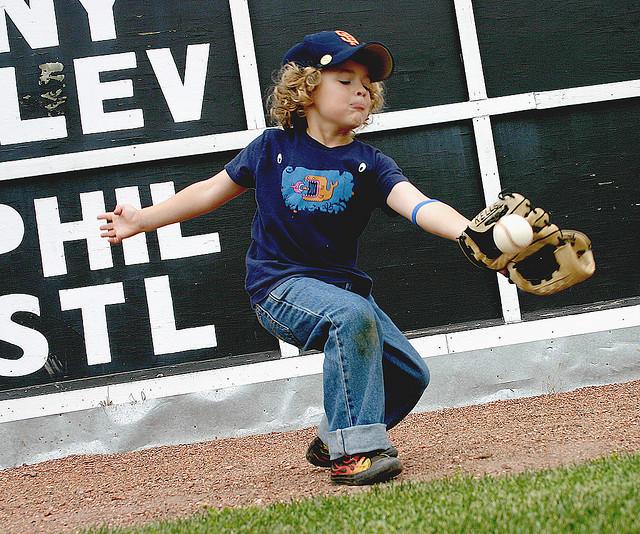Is the child's hair curly?
Write a very short answer. Yes. Which hand is the boy wearing his glove on?
Answer briefly. Left. What is the boys hat color?
Write a very short answer. Blue. 